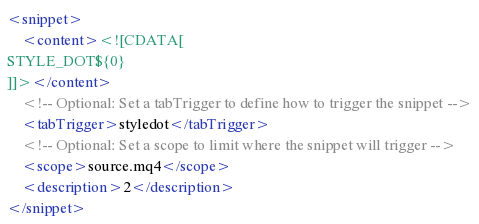<code> <loc_0><loc_0><loc_500><loc_500><_XML_><snippet>
	<content><![CDATA[
STYLE_DOT${0}
]]></content>
	<!-- Optional: Set a tabTrigger to define how to trigger the snippet -->
	<tabTrigger>styledot</tabTrigger>
	<!-- Optional: Set a scope to limit where the snippet will trigger -->
	<scope>source.mq4</scope>
	<description>2</description>
</snippet>
</code> 